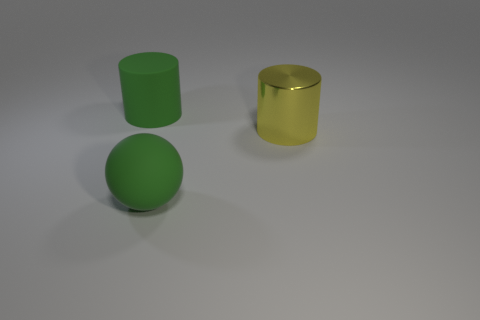The big object that is left of the large green thing in front of the cylinder to the right of the rubber cylinder is made of what material?
Your answer should be compact. Rubber. What shape is the large green thing that is the same material as the green cylinder?
Your answer should be compact. Sphere. Is there any other thing that has the same color as the big matte ball?
Provide a short and direct response. Yes. There is a yellow object that is behind the green rubber object that is in front of the yellow cylinder; how many large green rubber cylinders are in front of it?
Your answer should be very brief. 0. What number of gray objects are either small metallic cubes or metal objects?
Provide a succinct answer. 0. Do the yellow shiny cylinder and the green object behind the big green matte ball have the same size?
Keep it short and to the point. Yes. There is another green object that is the same shape as the big shiny thing; what material is it?
Give a very brief answer. Rubber. How many other objects are there of the same size as the yellow metal cylinder?
Make the answer very short. 2. There is a large thing that is in front of the cylinder right of the green rubber object on the left side of the ball; what shape is it?
Give a very brief answer. Sphere. What shape is the object that is both behind the big matte sphere and left of the shiny object?
Ensure brevity in your answer.  Cylinder. 